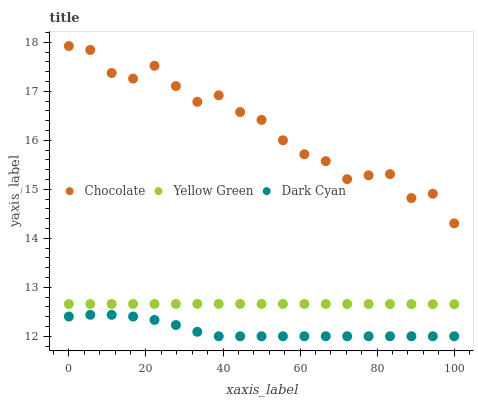Does Dark Cyan have the minimum area under the curve?
Answer yes or no. Yes. Does Chocolate have the maximum area under the curve?
Answer yes or no. Yes. Does Yellow Green have the minimum area under the curve?
Answer yes or no. No. Does Yellow Green have the maximum area under the curve?
Answer yes or no. No. Is Yellow Green the smoothest?
Answer yes or no. Yes. Is Chocolate the roughest?
Answer yes or no. Yes. Is Chocolate the smoothest?
Answer yes or no. No. Is Yellow Green the roughest?
Answer yes or no. No. Does Dark Cyan have the lowest value?
Answer yes or no. Yes. Does Yellow Green have the lowest value?
Answer yes or no. No. Does Chocolate have the highest value?
Answer yes or no. Yes. Does Yellow Green have the highest value?
Answer yes or no. No. Is Dark Cyan less than Chocolate?
Answer yes or no. Yes. Is Yellow Green greater than Dark Cyan?
Answer yes or no. Yes. Does Dark Cyan intersect Chocolate?
Answer yes or no. No. 